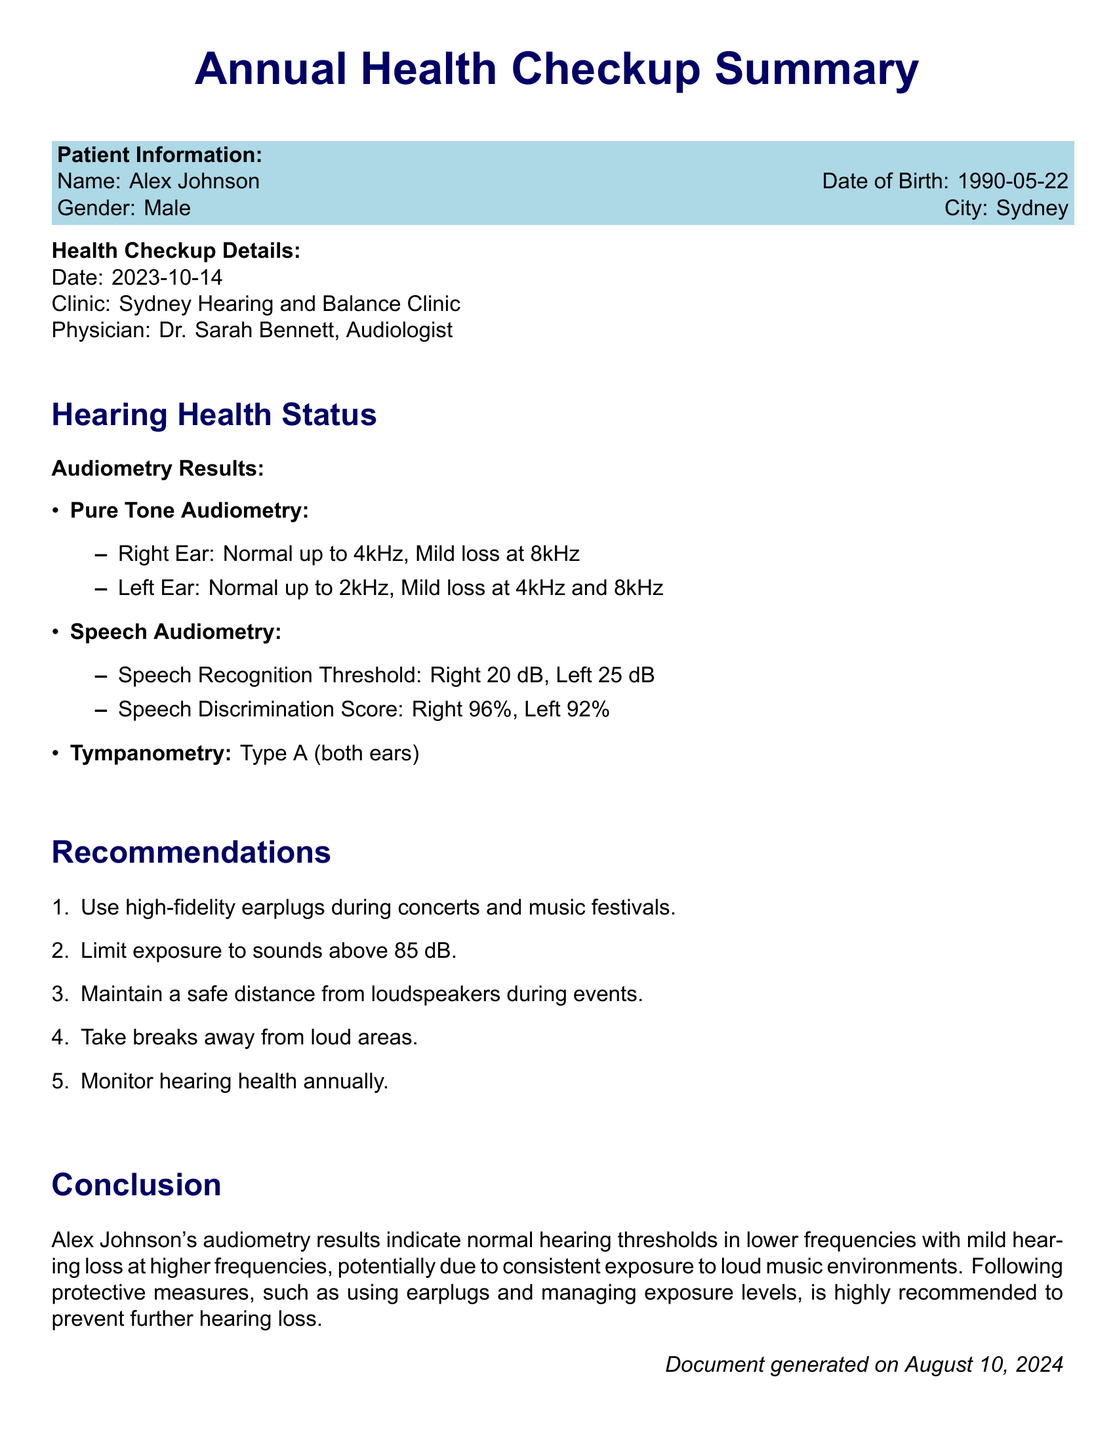What is the patient's name? The patient's name is listed in the document under Patient Information.
Answer: Alex Johnson What is the date of birth? The date of birth is provided in the Patient Information section of the document.
Answer: 1990-05-22 Who is the physician? The physician's name is mentioned in the Health Checkup Details section.
Answer: Dr. Sarah Bennett What were the Audiometry results for the right ear? The results for the right ear are detailed under Audiometry Results.
Answer: Normal up to 4kHz, Mild loss at 8kHz What is the recommended action regarding exposure to sounds? The recommendations provide guidance on protecting hearing during loud sounds.
Answer: Limit exposure to sounds above 85 dB What type of tympanometry result is recorded? The type of tympanometry is indicated in the Audiometry Results.
Answer: Type A (both ears) How often should hearing health be monitored? The recommendations mention the frequency of hearing health monitoring.
Answer: Annually What conclusion is drawn regarding hearing loss? The conclusion summarizes the overall findings of the hearing health status.
Answer: Potentially due to consistent exposure to loud music environments What should be used during concerts? The document provides a specific suggestion for concert goers.
Answer: High-fidelity earplugs 